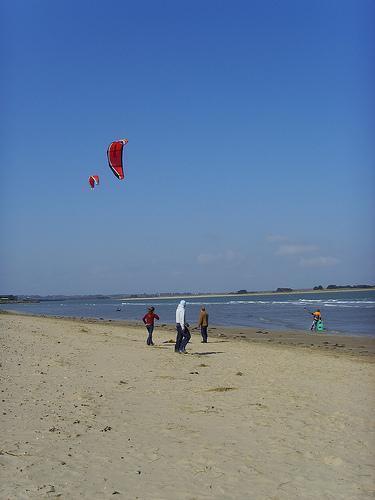How many kites are there?
Give a very brief answer. 2. How many people are visible?
Give a very brief answer. 4. 